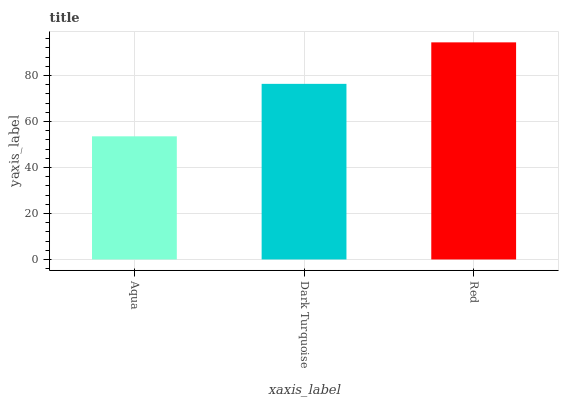Is Aqua the minimum?
Answer yes or no. Yes. Is Red the maximum?
Answer yes or no. Yes. Is Dark Turquoise the minimum?
Answer yes or no. No. Is Dark Turquoise the maximum?
Answer yes or no. No. Is Dark Turquoise greater than Aqua?
Answer yes or no. Yes. Is Aqua less than Dark Turquoise?
Answer yes or no. Yes. Is Aqua greater than Dark Turquoise?
Answer yes or no. No. Is Dark Turquoise less than Aqua?
Answer yes or no. No. Is Dark Turquoise the high median?
Answer yes or no. Yes. Is Dark Turquoise the low median?
Answer yes or no. Yes. Is Red the high median?
Answer yes or no. No. Is Red the low median?
Answer yes or no. No. 